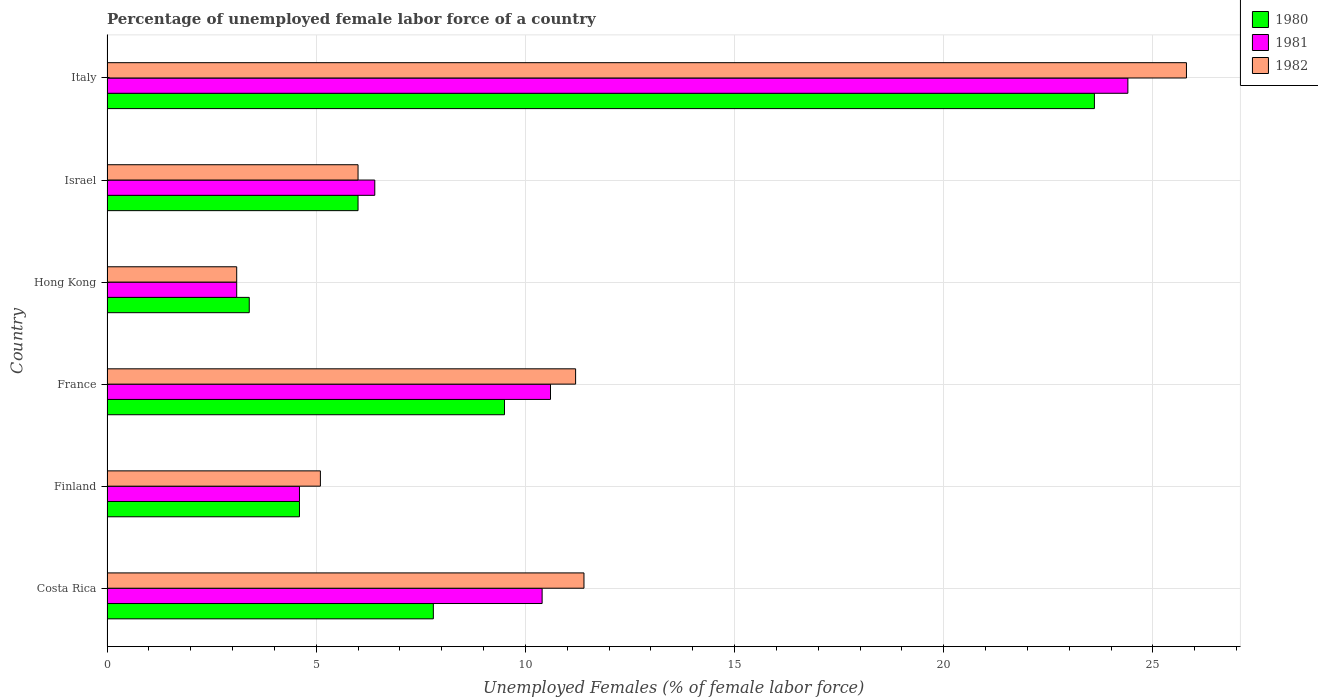How many different coloured bars are there?
Ensure brevity in your answer.  3. How many bars are there on the 4th tick from the top?
Give a very brief answer. 3. How many bars are there on the 1st tick from the bottom?
Give a very brief answer. 3. In how many cases, is the number of bars for a given country not equal to the number of legend labels?
Your answer should be very brief. 0. What is the percentage of unemployed female labor force in 1982 in France?
Your response must be concise. 11.2. Across all countries, what is the maximum percentage of unemployed female labor force in 1980?
Your answer should be compact. 23.6. Across all countries, what is the minimum percentage of unemployed female labor force in 1980?
Make the answer very short. 3.4. In which country was the percentage of unemployed female labor force in 1981 maximum?
Ensure brevity in your answer.  Italy. In which country was the percentage of unemployed female labor force in 1982 minimum?
Make the answer very short. Hong Kong. What is the total percentage of unemployed female labor force in 1982 in the graph?
Your response must be concise. 62.6. What is the difference between the percentage of unemployed female labor force in 1980 in Costa Rica and that in France?
Offer a very short reply. -1.7. What is the difference between the percentage of unemployed female labor force in 1981 in Israel and the percentage of unemployed female labor force in 1980 in Hong Kong?
Keep it short and to the point. 3. What is the average percentage of unemployed female labor force in 1980 per country?
Give a very brief answer. 9.15. What is the difference between the percentage of unemployed female labor force in 1980 and percentage of unemployed female labor force in 1981 in Israel?
Offer a terse response. -0.4. In how many countries, is the percentage of unemployed female labor force in 1982 greater than 13 %?
Offer a very short reply. 1. What is the ratio of the percentage of unemployed female labor force in 1980 in Costa Rica to that in Italy?
Offer a very short reply. 0.33. Is the percentage of unemployed female labor force in 1981 in Finland less than that in Italy?
Offer a very short reply. Yes. Is the difference between the percentage of unemployed female labor force in 1980 in Costa Rica and Israel greater than the difference between the percentage of unemployed female labor force in 1981 in Costa Rica and Israel?
Your answer should be very brief. No. What is the difference between the highest and the second highest percentage of unemployed female labor force in 1980?
Your answer should be very brief. 14.1. What is the difference between the highest and the lowest percentage of unemployed female labor force in 1981?
Give a very brief answer. 21.3. What does the 3rd bar from the top in Italy represents?
Offer a terse response. 1980. What does the 1st bar from the bottom in Israel represents?
Your answer should be compact. 1980. How many bars are there?
Ensure brevity in your answer.  18. Are all the bars in the graph horizontal?
Ensure brevity in your answer.  Yes. Does the graph contain any zero values?
Provide a succinct answer. No. How many legend labels are there?
Give a very brief answer. 3. What is the title of the graph?
Offer a terse response. Percentage of unemployed female labor force of a country. What is the label or title of the X-axis?
Provide a succinct answer. Unemployed Females (% of female labor force). What is the Unemployed Females (% of female labor force) in 1980 in Costa Rica?
Keep it short and to the point. 7.8. What is the Unemployed Females (% of female labor force) in 1981 in Costa Rica?
Make the answer very short. 10.4. What is the Unemployed Females (% of female labor force) in 1982 in Costa Rica?
Make the answer very short. 11.4. What is the Unemployed Females (% of female labor force) in 1980 in Finland?
Your answer should be very brief. 4.6. What is the Unemployed Females (% of female labor force) of 1981 in Finland?
Ensure brevity in your answer.  4.6. What is the Unemployed Females (% of female labor force) of 1982 in Finland?
Give a very brief answer. 5.1. What is the Unemployed Females (% of female labor force) of 1980 in France?
Ensure brevity in your answer.  9.5. What is the Unemployed Females (% of female labor force) of 1981 in France?
Your response must be concise. 10.6. What is the Unemployed Females (% of female labor force) of 1982 in France?
Your answer should be very brief. 11.2. What is the Unemployed Females (% of female labor force) in 1980 in Hong Kong?
Provide a succinct answer. 3.4. What is the Unemployed Females (% of female labor force) in 1981 in Hong Kong?
Provide a succinct answer. 3.1. What is the Unemployed Females (% of female labor force) in 1982 in Hong Kong?
Offer a terse response. 3.1. What is the Unemployed Females (% of female labor force) in 1981 in Israel?
Offer a terse response. 6.4. What is the Unemployed Females (% of female labor force) of 1980 in Italy?
Offer a very short reply. 23.6. What is the Unemployed Females (% of female labor force) of 1981 in Italy?
Ensure brevity in your answer.  24.4. What is the Unemployed Females (% of female labor force) in 1982 in Italy?
Your answer should be very brief. 25.8. Across all countries, what is the maximum Unemployed Females (% of female labor force) of 1980?
Provide a succinct answer. 23.6. Across all countries, what is the maximum Unemployed Females (% of female labor force) of 1981?
Keep it short and to the point. 24.4. Across all countries, what is the maximum Unemployed Females (% of female labor force) of 1982?
Offer a very short reply. 25.8. Across all countries, what is the minimum Unemployed Females (% of female labor force) of 1980?
Provide a succinct answer. 3.4. Across all countries, what is the minimum Unemployed Females (% of female labor force) in 1981?
Your response must be concise. 3.1. Across all countries, what is the minimum Unemployed Females (% of female labor force) in 1982?
Offer a terse response. 3.1. What is the total Unemployed Females (% of female labor force) of 1980 in the graph?
Offer a very short reply. 54.9. What is the total Unemployed Females (% of female labor force) of 1981 in the graph?
Keep it short and to the point. 59.5. What is the total Unemployed Females (% of female labor force) in 1982 in the graph?
Provide a succinct answer. 62.6. What is the difference between the Unemployed Females (% of female labor force) in 1982 in Costa Rica and that in France?
Offer a terse response. 0.2. What is the difference between the Unemployed Females (% of female labor force) in 1982 in Costa Rica and that in Hong Kong?
Offer a very short reply. 8.3. What is the difference between the Unemployed Females (% of female labor force) of 1980 in Costa Rica and that in Italy?
Offer a terse response. -15.8. What is the difference between the Unemployed Females (% of female labor force) in 1982 in Costa Rica and that in Italy?
Your answer should be very brief. -14.4. What is the difference between the Unemployed Females (% of female labor force) in 1980 in Finland and that in France?
Your answer should be compact. -4.9. What is the difference between the Unemployed Females (% of female labor force) in 1981 in Finland and that in France?
Your answer should be very brief. -6. What is the difference between the Unemployed Females (% of female labor force) in 1982 in Finland and that in France?
Your answer should be very brief. -6.1. What is the difference between the Unemployed Females (% of female labor force) of 1981 in Finland and that in Hong Kong?
Your response must be concise. 1.5. What is the difference between the Unemployed Females (% of female labor force) in 1982 in Finland and that in Hong Kong?
Your response must be concise. 2. What is the difference between the Unemployed Females (% of female labor force) of 1982 in Finland and that in Israel?
Your answer should be compact. -0.9. What is the difference between the Unemployed Females (% of female labor force) in 1980 in Finland and that in Italy?
Keep it short and to the point. -19. What is the difference between the Unemployed Females (% of female labor force) of 1981 in Finland and that in Italy?
Your answer should be compact. -19.8. What is the difference between the Unemployed Females (% of female labor force) of 1982 in Finland and that in Italy?
Provide a succinct answer. -20.7. What is the difference between the Unemployed Females (% of female labor force) in 1981 in France and that in Hong Kong?
Offer a terse response. 7.5. What is the difference between the Unemployed Females (% of female labor force) in 1980 in France and that in Israel?
Offer a very short reply. 3.5. What is the difference between the Unemployed Females (% of female labor force) in 1981 in France and that in Israel?
Make the answer very short. 4.2. What is the difference between the Unemployed Females (% of female labor force) of 1982 in France and that in Israel?
Your answer should be very brief. 5.2. What is the difference between the Unemployed Females (% of female labor force) of 1980 in France and that in Italy?
Your response must be concise. -14.1. What is the difference between the Unemployed Females (% of female labor force) of 1982 in France and that in Italy?
Make the answer very short. -14.6. What is the difference between the Unemployed Females (% of female labor force) in 1982 in Hong Kong and that in Israel?
Provide a short and direct response. -2.9. What is the difference between the Unemployed Females (% of female labor force) of 1980 in Hong Kong and that in Italy?
Offer a terse response. -20.2. What is the difference between the Unemployed Females (% of female labor force) in 1981 in Hong Kong and that in Italy?
Your answer should be compact. -21.3. What is the difference between the Unemployed Females (% of female labor force) of 1982 in Hong Kong and that in Italy?
Offer a very short reply. -22.7. What is the difference between the Unemployed Females (% of female labor force) in 1980 in Israel and that in Italy?
Provide a short and direct response. -17.6. What is the difference between the Unemployed Females (% of female labor force) in 1981 in Israel and that in Italy?
Provide a short and direct response. -18. What is the difference between the Unemployed Females (% of female labor force) in 1982 in Israel and that in Italy?
Offer a very short reply. -19.8. What is the difference between the Unemployed Females (% of female labor force) in 1981 in Costa Rica and the Unemployed Females (% of female labor force) in 1982 in Finland?
Offer a very short reply. 5.3. What is the difference between the Unemployed Females (% of female labor force) in 1980 in Costa Rica and the Unemployed Females (% of female labor force) in 1982 in France?
Ensure brevity in your answer.  -3.4. What is the difference between the Unemployed Females (% of female labor force) in 1980 in Costa Rica and the Unemployed Females (% of female labor force) in 1982 in Hong Kong?
Ensure brevity in your answer.  4.7. What is the difference between the Unemployed Females (% of female labor force) in 1981 in Costa Rica and the Unemployed Females (% of female labor force) in 1982 in Hong Kong?
Offer a very short reply. 7.3. What is the difference between the Unemployed Females (% of female labor force) in 1980 in Costa Rica and the Unemployed Females (% of female labor force) in 1981 in Israel?
Your response must be concise. 1.4. What is the difference between the Unemployed Females (% of female labor force) in 1980 in Costa Rica and the Unemployed Females (% of female labor force) in 1981 in Italy?
Keep it short and to the point. -16.6. What is the difference between the Unemployed Females (% of female labor force) in 1981 in Costa Rica and the Unemployed Females (% of female labor force) in 1982 in Italy?
Keep it short and to the point. -15.4. What is the difference between the Unemployed Females (% of female labor force) in 1980 in Finland and the Unemployed Females (% of female labor force) in 1981 in France?
Provide a succinct answer. -6. What is the difference between the Unemployed Females (% of female labor force) in 1981 in Finland and the Unemployed Females (% of female labor force) in 1982 in France?
Your response must be concise. -6.6. What is the difference between the Unemployed Females (% of female labor force) in 1980 in Finland and the Unemployed Females (% of female labor force) in 1981 in Hong Kong?
Your answer should be compact. 1.5. What is the difference between the Unemployed Females (% of female labor force) in 1980 in Finland and the Unemployed Females (% of female labor force) in 1982 in Hong Kong?
Your response must be concise. 1.5. What is the difference between the Unemployed Females (% of female labor force) of 1981 in Finland and the Unemployed Females (% of female labor force) of 1982 in Israel?
Offer a very short reply. -1.4. What is the difference between the Unemployed Females (% of female labor force) in 1980 in Finland and the Unemployed Females (% of female labor force) in 1981 in Italy?
Provide a short and direct response. -19.8. What is the difference between the Unemployed Females (% of female labor force) of 1980 in Finland and the Unemployed Females (% of female labor force) of 1982 in Italy?
Provide a succinct answer. -21.2. What is the difference between the Unemployed Females (% of female labor force) in 1981 in Finland and the Unemployed Females (% of female labor force) in 1982 in Italy?
Your answer should be very brief. -21.2. What is the difference between the Unemployed Females (% of female labor force) in 1980 in France and the Unemployed Females (% of female labor force) in 1981 in Hong Kong?
Your answer should be very brief. 6.4. What is the difference between the Unemployed Females (% of female labor force) of 1981 in France and the Unemployed Females (% of female labor force) of 1982 in Hong Kong?
Offer a very short reply. 7.5. What is the difference between the Unemployed Females (% of female labor force) in 1980 in France and the Unemployed Females (% of female labor force) in 1981 in Israel?
Ensure brevity in your answer.  3.1. What is the difference between the Unemployed Females (% of female labor force) in 1980 in France and the Unemployed Females (% of female labor force) in 1981 in Italy?
Provide a succinct answer. -14.9. What is the difference between the Unemployed Females (% of female labor force) of 1980 in France and the Unemployed Females (% of female labor force) of 1982 in Italy?
Your response must be concise. -16.3. What is the difference between the Unemployed Females (% of female labor force) in 1981 in France and the Unemployed Females (% of female labor force) in 1982 in Italy?
Your response must be concise. -15.2. What is the difference between the Unemployed Females (% of female labor force) in 1980 in Hong Kong and the Unemployed Females (% of female labor force) in 1981 in Israel?
Offer a very short reply. -3. What is the difference between the Unemployed Females (% of female labor force) in 1980 in Hong Kong and the Unemployed Females (% of female labor force) in 1982 in Israel?
Provide a short and direct response. -2.6. What is the difference between the Unemployed Females (% of female labor force) of 1980 in Hong Kong and the Unemployed Females (% of female labor force) of 1981 in Italy?
Ensure brevity in your answer.  -21. What is the difference between the Unemployed Females (% of female labor force) in 1980 in Hong Kong and the Unemployed Females (% of female labor force) in 1982 in Italy?
Your answer should be very brief. -22.4. What is the difference between the Unemployed Females (% of female labor force) in 1981 in Hong Kong and the Unemployed Females (% of female labor force) in 1982 in Italy?
Provide a short and direct response. -22.7. What is the difference between the Unemployed Females (% of female labor force) in 1980 in Israel and the Unemployed Females (% of female labor force) in 1981 in Italy?
Provide a short and direct response. -18.4. What is the difference between the Unemployed Females (% of female labor force) in 1980 in Israel and the Unemployed Females (% of female labor force) in 1982 in Italy?
Your response must be concise. -19.8. What is the difference between the Unemployed Females (% of female labor force) in 1981 in Israel and the Unemployed Females (% of female labor force) in 1982 in Italy?
Offer a terse response. -19.4. What is the average Unemployed Females (% of female labor force) in 1980 per country?
Provide a succinct answer. 9.15. What is the average Unemployed Females (% of female labor force) of 1981 per country?
Make the answer very short. 9.92. What is the average Unemployed Females (% of female labor force) of 1982 per country?
Give a very brief answer. 10.43. What is the difference between the Unemployed Females (% of female labor force) of 1980 and Unemployed Females (% of female labor force) of 1982 in Costa Rica?
Keep it short and to the point. -3.6. What is the difference between the Unemployed Females (% of female labor force) in 1981 and Unemployed Females (% of female labor force) in 1982 in Costa Rica?
Offer a very short reply. -1. What is the difference between the Unemployed Females (% of female labor force) of 1980 and Unemployed Females (% of female labor force) of 1981 in Finland?
Provide a short and direct response. 0. What is the difference between the Unemployed Females (% of female labor force) of 1981 and Unemployed Females (% of female labor force) of 1982 in Finland?
Ensure brevity in your answer.  -0.5. What is the difference between the Unemployed Females (% of female labor force) in 1980 and Unemployed Females (% of female labor force) in 1981 in France?
Offer a terse response. -1.1. What is the difference between the Unemployed Females (% of female labor force) of 1980 and Unemployed Females (% of female labor force) of 1982 in France?
Your response must be concise. -1.7. What is the difference between the Unemployed Females (% of female labor force) in 1981 and Unemployed Females (% of female labor force) in 1982 in France?
Provide a short and direct response. -0.6. What is the difference between the Unemployed Females (% of female labor force) of 1980 and Unemployed Females (% of female labor force) of 1981 in Hong Kong?
Your answer should be very brief. 0.3. What is the difference between the Unemployed Females (% of female labor force) of 1980 and Unemployed Females (% of female labor force) of 1981 in Israel?
Your response must be concise. -0.4. What is the ratio of the Unemployed Females (% of female labor force) of 1980 in Costa Rica to that in Finland?
Your response must be concise. 1.7. What is the ratio of the Unemployed Females (% of female labor force) in 1981 in Costa Rica to that in Finland?
Your response must be concise. 2.26. What is the ratio of the Unemployed Females (% of female labor force) of 1982 in Costa Rica to that in Finland?
Your response must be concise. 2.24. What is the ratio of the Unemployed Females (% of female labor force) of 1980 in Costa Rica to that in France?
Your answer should be very brief. 0.82. What is the ratio of the Unemployed Females (% of female labor force) of 1981 in Costa Rica to that in France?
Provide a short and direct response. 0.98. What is the ratio of the Unemployed Females (% of female labor force) of 1982 in Costa Rica to that in France?
Keep it short and to the point. 1.02. What is the ratio of the Unemployed Females (% of female labor force) of 1980 in Costa Rica to that in Hong Kong?
Your answer should be compact. 2.29. What is the ratio of the Unemployed Females (% of female labor force) of 1981 in Costa Rica to that in Hong Kong?
Make the answer very short. 3.35. What is the ratio of the Unemployed Females (% of female labor force) in 1982 in Costa Rica to that in Hong Kong?
Give a very brief answer. 3.68. What is the ratio of the Unemployed Females (% of female labor force) in 1980 in Costa Rica to that in Israel?
Provide a short and direct response. 1.3. What is the ratio of the Unemployed Females (% of female labor force) in 1981 in Costa Rica to that in Israel?
Your answer should be very brief. 1.62. What is the ratio of the Unemployed Females (% of female labor force) in 1980 in Costa Rica to that in Italy?
Your response must be concise. 0.33. What is the ratio of the Unemployed Females (% of female labor force) in 1981 in Costa Rica to that in Italy?
Make the answer very short. 0.43. What is the ratio of the Unemployed Females (% of female labor force) of 1982 in Costa Rica to that in Italy?
Your answer should be compact. 0.44. What is the ratio of the Unemployed Females (% of female labor force) in 1980 in Finland to that in France?
Provide a succinct answer. 0.48. What is the ratio of the Unemployed Females (% of female labor force) in 1981 in Finland to that in France?
Offer a very short reply. 0.43. What is the ratio of the Unemployed Females (% of female labor force) in 1982 in Finland to that in France?
Give a very brief answer. 0.46. What is the ratio of the Unemployed Females (% of female labor force) of 1980 in Finland to that in Hong Kong?
Offer a very short reply. 1.35. What is the ratio of the Unemployed Females (% of female labor force) in 1981 in Finland to that in Hong Kong?
Offer a terse response. 1.48. What is the ratio of the Unemployed Females (% of female labor force) in 1982 in Finland to that in Hong Kong?
Offer a terse response. 1.65. What is the ratio of the Unemployed Females (% of female labor force) of 1980 in Finland to that in Israel?
Offer a terse response. 0.77. What is the ratio of the Unemployed Females (% of female labor force) in 1981 in Finland to that in Israel?
Provide a succinct answer. 0.72. What is the ratio of the Unemployed Females (% of female labor force) in 1980 in Finland to that in Italy?
Provide a short and direct response. 0.19. What is the ratio of the Unemployed Females (% of female labor force) in 1981 in Finland to that in Italy?
Offer a very short reply. 0.19. What is the ratio of the Unemployed Females (% of female labor force) of 1982 in Finland to that in Italy?
Your answer should be compact. 0.2. What is the ratio of the Unemployed Females (% of female labor force) of 1980 in France to that in Hong Kong?
Ensure brevity in your answer.  2.79. What is the ratio of the Unemployed Females (% of female labor force) in 1981 in France to that in Hong Kong?
Give a very brief answer. 3.42. What is the ratio of the Unemployed Females (% of female labor force) of 1982 in France to that in Hong Kong?
Offer a very short reply. 3.61. What is the ratio of the Unemployed Females (% of female labor force) of 1980 in France to that in Israel?
Make the answer very short. 1.58. What is the ratio of the Unemployed Females (% of female labor force) of 1981 in France to that in Israel?
Make the answer very short. 1.66. What is the ratio of the Unemployed Females (% of female labor force) of 1982 in France to that in Israel?
Your answer should be compact. 1.87. What is the ratio of the Unemployed Females (% of female labor force) in 1980 in France to that in Italy?
Provide a short and direct response. 0.4. What is the ratio of the Unemployed Females (% of female labor force) in 1981 in France to that in Italy?
Ensure brevity in your answer.  0.43. What is the ratio of the Unemployed Females (% of female labor force) in 1982 in France to that in Italy?
Offer a terse response. 0.43. What is the ratio of the Unemployed Females (% of female labor force) of 1980 in Hong Kong to that in Israel?
Your answer should be compact. 0.57. What is the ratio of the Unemployed Females (% of female labor force) of 1981 in Hong Kong to that in Israel?
Offer a very short reply. 0.48. What is the ratio of the Unemployed Females (% of female labor force) of 1982 in Hong Kong to that in Israel?
Ensure brevity in your answer.  0.52. What is the ratio of the Unemployed Females (% of female labor force) of 1980 in Hong Kong to that in Italy?
Provide a succinct answer. 0.14. What is the ratio of the Unemployed Females (% of female labor force) in 1981 in Hong Kong to that in Italy?
Provide a succinct answer. 0.13. What is the ratio of the Unemployed Females (% of female labor force) in 1982 in Hong Kong to that in Italy?
Make the answer very short. 0.12. What is the ratio of the Unemployed Females (% of female labor force) of 1980 in Israel to that in Italy?
Make the answer very short. 0.25. What is the ratio of the Unemployed Females (% of female labor force) of 1981 in Israel to that in Italy?
Make the answer very short. 0.26. What is the ratio of the Unemployed Females (% of female labor force) in 1982 in Israel to that in Italy?
Your answer should be very brief. 0.23. What is the difference between the highest and the second highest Unemployed Females (% of female labor force) of 1980?
Make the answer very short. 14.1. What is the difference between the highest and the second highest Unemployed Females (% of female labor force) in 1981?
Your answer should be very brief. 13.8. What is the difference between the highest and the second highest Unemployed Females (% of female labor force) of 1982?
Give a very brief answer. 14.4. What is the difference between the highest and the lowest Unemployed Females (% of female labor force) in 1980?
Give a very brief answer. 20.2. What is the difference between the highest and the lowest Unemployed Females (% of female labor force) in 1981?
Provide a succinct answer. 21.3. What is the difference between the highest and the lowest Unemployed Females (% of female labor force) in 1982?
Keep it short and to the point. 22.7. 